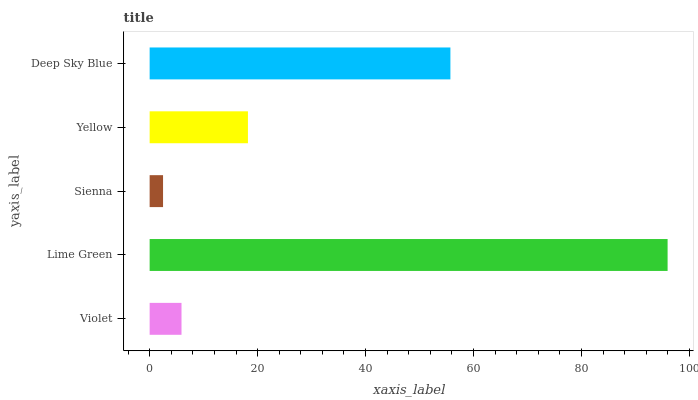Is Sienna the minimum?
Answer yes or no. Yes. Is Lime Green the maximum?
Answer yes or no. Yes. Is Lime Green the minimum?
Answer yes or no. No. Is Sienna the maximum?
Answer yes or no. No. Is Lime Green greater than Sienna?
Answer yes or no. Yes. Is Sienna less than Lime Green?
Answer yes or no. Yes. Is Sienna greater than Lime Green?
Answer yes or no. No. Is Lime Green less than Sienna?
Answer yes or no. No. Is Yellow the high median?
Answer yes or no. Yes. Is Yellow the low median?
Answer yes or no. Yes. Is Lime Green the high median?
Answer yes or no. No. Is Sienna the low median?
Answer yes or no. No. 